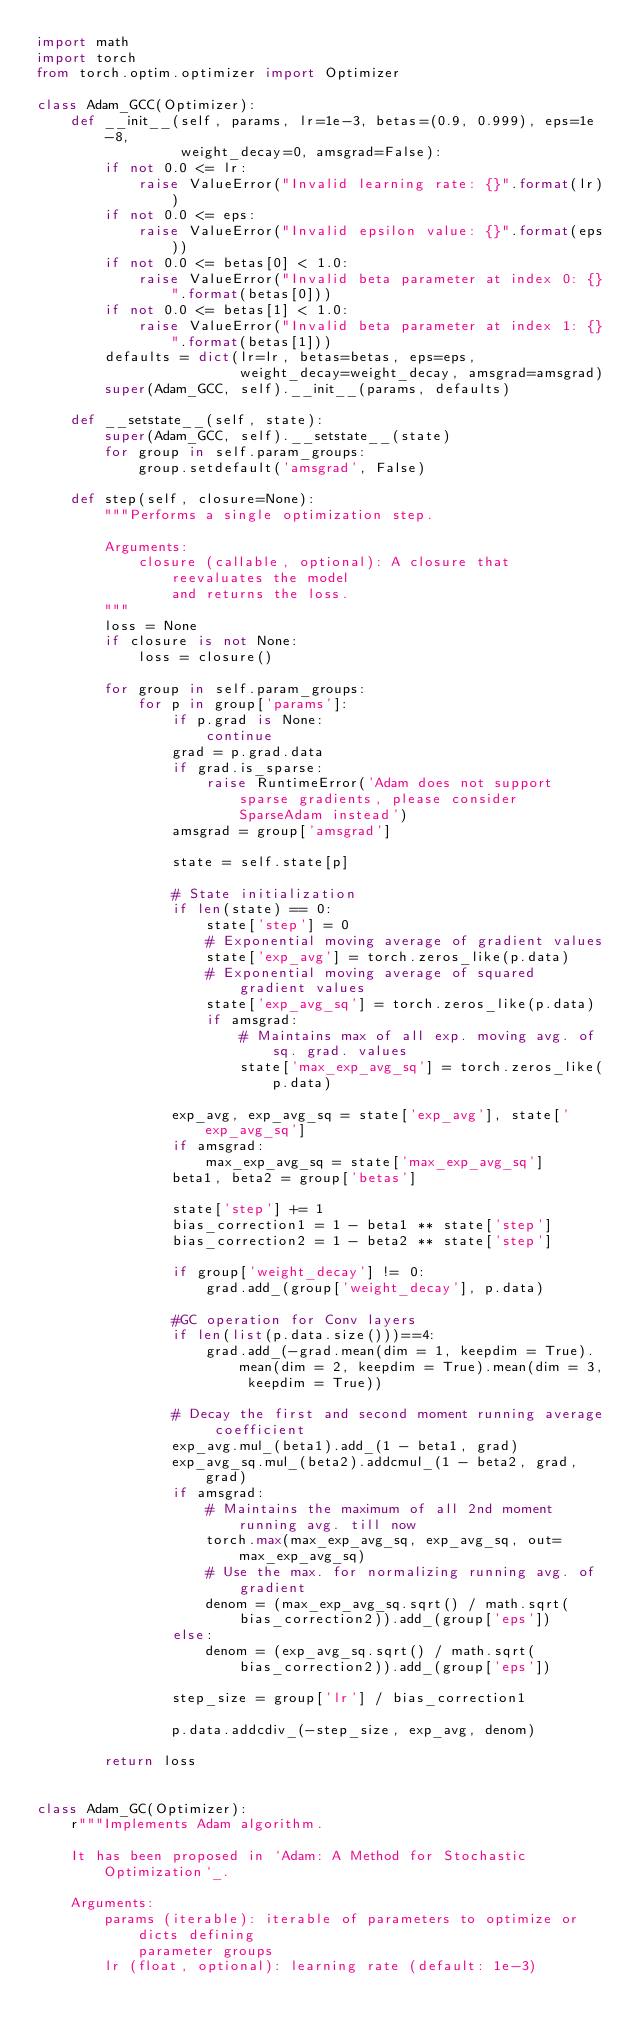<code> <loc_0><loc_0><loc_500><loc_500><_Python_>import math
import torch
from torch.optim.optimizer import Optimizer

class Adam_GCC(Optimizer):
    def __init__(self, params, lr=1e-3, betas=(0.9, 0.999), eps=1e-8,
                 weight_decay=0, amsgrad=False):
        if not 0.0 <= lr:
            raise ValueError("Invalid learning rate: {}".format(lr))
        if not 0.0 <= eps:
            raise ValueError("Invalid epsilon value: {}".format(eps))
        if not 0.0 <= betas[0] < 1.0:
            raise ValueError("Invalid beta parameter at index 0: {}".format(betas[0]))
        if not 0.0 <= betas[1] < 1.0:
            raise ValueError("Invalid beta parameter at index 1: {}".format(betas[1]))
        defaults = dict(lr=lr, betas=betas, eps=eps,
                        weight_decay=weight_decay, amsgrad=amsgrad)
        super(Adam_GCC, self).__init__(params, defaults)

    def __setstate__(self, state):
        super(Adam_GCC, self).__setstate__(state)
        for group in self.param_groups:
            group.setdefault('amsgrad', False)

    def step(self, closure=None):
        """Performs a single optimization step.

        Arguments:
            closure (callable, optional): A closure that reevaluates the model
                and returns the loss.
        """
        loss = None
        if closure is not None:
            loss = closure()

        for group in self.param_groups:
            for p in group['params']:
                if p.grad is None:
                    continue
                grad = p.grad.data
                if grad.is_sparse:
                    raise RuntimeError('Adam does not support sparse gradients, please consider SparseAdam instead')
                amsgrad = group['amsgrad']

                state = self.state[p]

                # State initialization
                if len(state) == 0:
                    state['step'] = 0
                    # Exponential moving average of gradient values
                    state['exp_avg'] = torch.zeros_like(p.data)
                    # Exponential moving average of squared gradient values
                    state['exp_avg_sq'] = torch.zeros_like(p.data)
                    if amsgrad:
                        # Maintains max of all exp. moving avg. of sq. grad. values
                        state['max_exp_avg_sq'] = torch.zeros_like(p.data)

                exp_avg, exp_avg_sq = state['exp_avg'], state['exp_avg_sq']
                if amsgrad:
                    max_exp_avg_sq = state['max_exp_avg_sq']
                beta1, beta2 = group['betas']

                state['step'] += 1
                bias_correction1 = 1 - beta1 ** state['step']
                bias_correction2 = 1 - beta2 ** state['step']

                if group['weight_decay'] != 0:
                    grad.add_(group['weight_decay'], p.data)

                #GC operation for Conv layers
                if len(list(p.data.size()))==4:
                    grad.add_(-grad.mean(dim = 1, keepdim = True).mean(dim = 2, keepdim = True).mean(dim = 3, keepdim = True))

                # Decay the first and second moment running average coefficient
                exp_avg.mul_(beta1).add_(1 - beta1, grad)
                exp_avg_sq.mul_(beta2).addcmul_(1 - beta2, grad, grad)
                if amsgrad:
                    # Maintains the maximum of all 2nd moment running avg. till now
                    torch.max(max_exp_avg_sq, exp_avg_sq, out=max_exp_avg_sq)
                    # Use the max. for normalizing running avg. of gradient
                    denom = (max_exp_avg_sq.sqrt() / math.sqrt(bias_correction2)).add_(group['eps'])
                else:
                    denom = (exp_avg_sq.sqrt() / math.sqrt(bias_correction2)).add_(group['eps'])

                step_size = group['lr'] / bias_correction1

                p.data.addcdiv_(-step_size, exp_avg, denom)

        return loss


class Adam_GC(Optimizer):
    r"""Implements Adam algorithm.

    It has been proposed in `Adam: A Method for Stochastic Optimization`_.

    Arguments:
        params (iterable): iterable of parameters to optimize or dicts defining
            parameter groups
        lr (float, optional): learning rate (default: 1e-3)</code> 